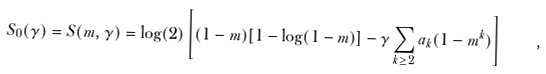Convert formula to latex. <formula><loc_0><loc_0><loc_500><loc_500>S _ { 0 } ( \gamma ) = S ( m , \gamma ) = \log ( 2 ) \left [ ( 1 - m ) [ 1 - \log ( 1 - m ) ] - \gamma \sum _ { k \geq 2 } a _ { k } ( 1 - m ^ { k } ) \right ] \quad ,</formula> 